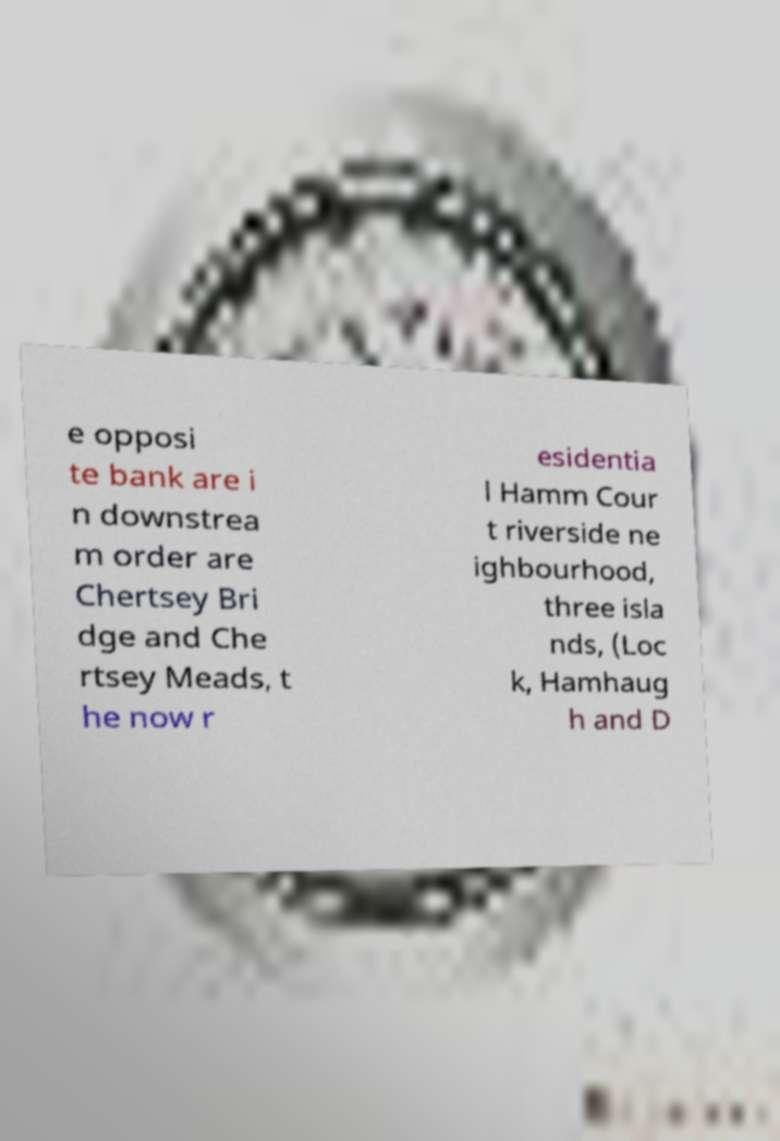Please identify and transcribe the text found in this image. e opposi te bank are i n downstrea m order are Chertsey Bri dge and Che rtsey Meads, t he now r esidentia l Hamm Cour t riverside ne ighbourhood, three isla nds, (Loc k, Hamhaug h and D 